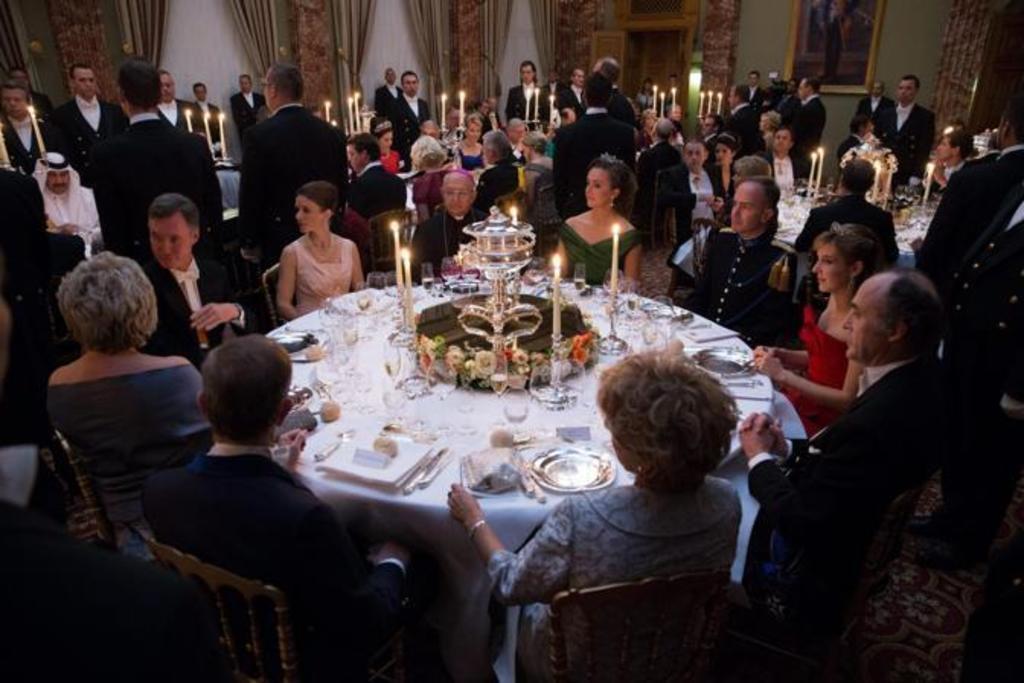Could you give a brief overview of what you see in this image? There are many people sitting in a wall around a table. They are having a food. There are some lights on each table. Some of the men are standing. There are women and men in the group. 